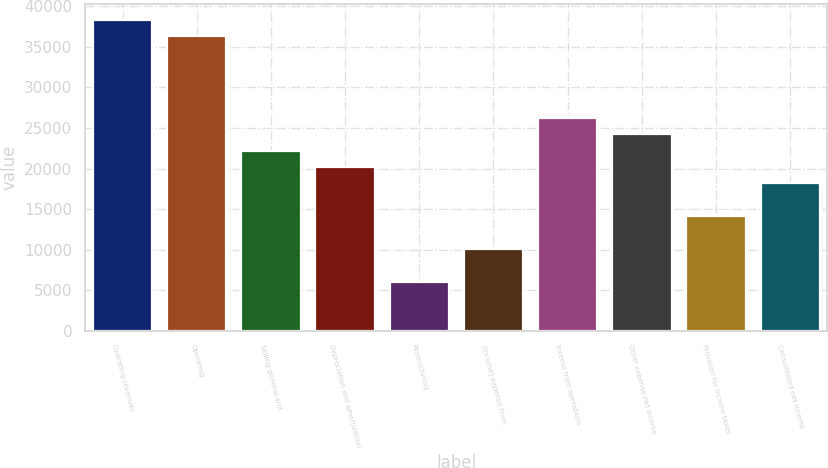Convert chart. <chart><loc_0><loc_0><loc_500><loc_500><bar_chart><fcel>Operating revenues<fcel>Operating<fcel>Selling general and<fcel>Depreciation and amortization<fcel>Restructuring<fcel>(Income) expense from<fcel>Income from operations<fcel>Other expense net Income<fcel>Provision for income taxes<fcel>Consolidated net income<nl><fcel>38331.6<fcel>36314.2<fcel>22192.4<fcel>20175<fcel>6053.16<fcel>10088<fcel>26227.2<fcel>24209.8<fcel>14122.8<fcel>18157.6<nl></chart> 